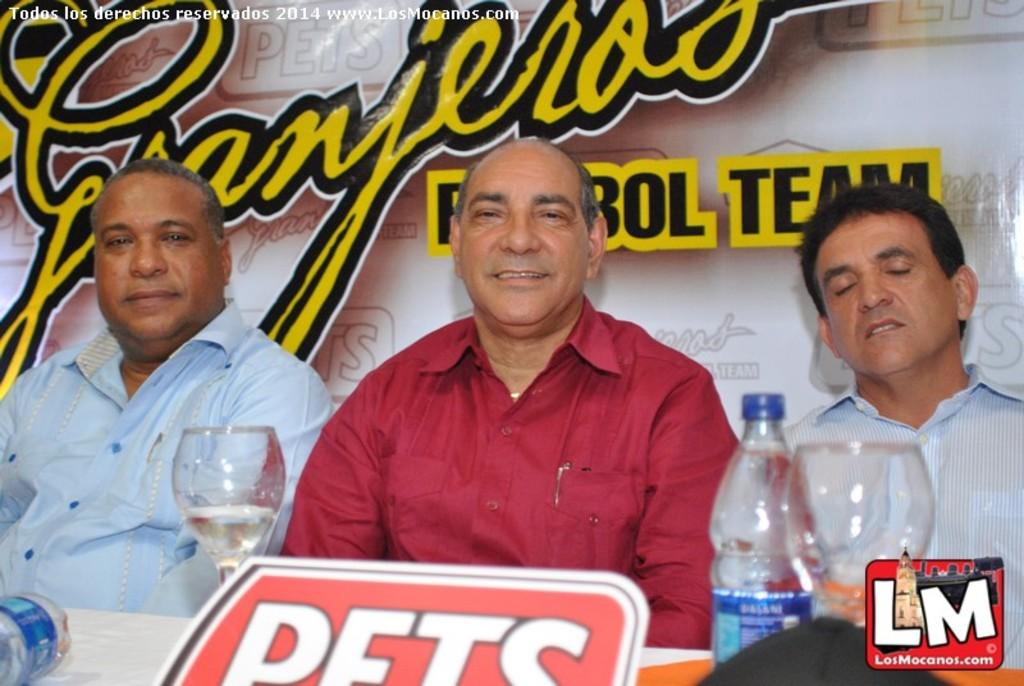<image>
Relay a brief, clear account of the picture shown. Three men with with a Granjeros sign behind them. 